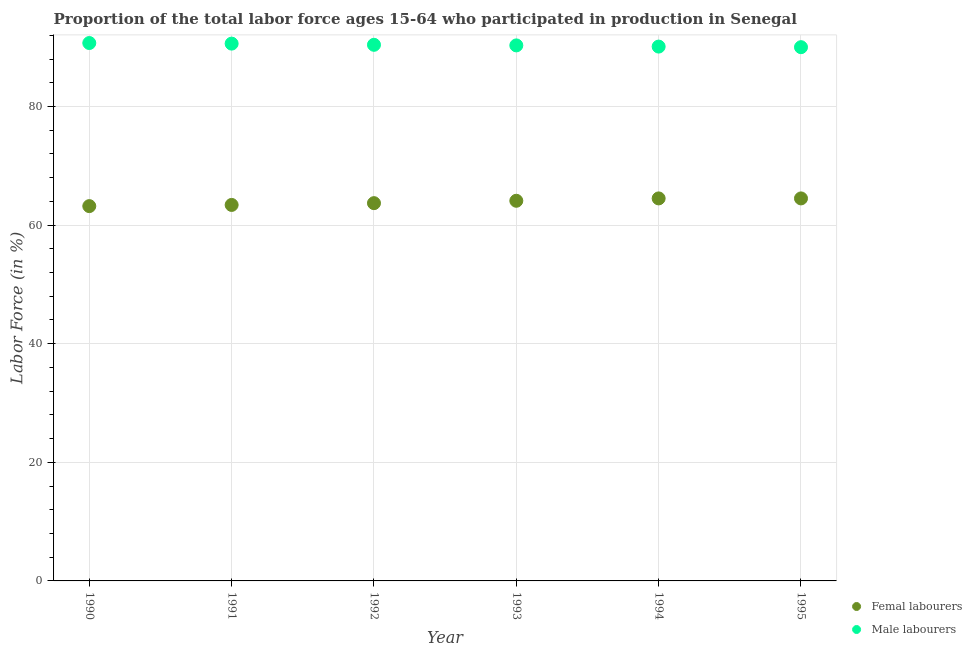How many different coloured dotlines are there?
Provide a succinct answer. 2. What is the percentage of male labour force in 1992?
Provide a short and direct response. 90.4. Across all years, what is the maximum percentage of male labour force?
Your response must be concise. 90.7. Across all years, what is the minimum percentage of male labour force?
Give a very brief answer. 90. In which year was the percentage of female labor force maximum?
Your response must be concise. 1994. What is the total percentage of female labor force in the graph?
Your response must be concise. 383.4. What is the difference between the percentage of male labour force in 1990 and that in 1993?
Keep it short and to the point. 0.4. What is the difference between the percentage of male labour force in 1994 and the percentage of female labor force in 1995?
Offer a terse response. 25.6. What is the average percentage of male labour force per year?
Ensure brevity in your answer.  90.35. In the year 1991, what is the difference between the percentage of female labor force and percentage of male labour force?
Your answer should be compact. -27.2. In how many years, is the percentage of female labor force greater than 4 %?
Provide a succinct answer. 6. What is the ratio of the percentage of female labor force in 1990 to that in 1992?
Your answer should be very brief. 0.99. What is the difference between the highest and the second highest percentage of male labour force?
Offer a terse response. 0.1. What is the difference between the highest and the lowest percentage of female labor force?
Your response must be concise. 1.3. In how many years, is the percentage of male labour force greater than the average percentage of male labour force taken over all years?
Provide a succinct answer. 3. Is the sum of the percentage of male labour force in 1990 and 1992 greater than the maximum percentage of female labor force across all years?
Your answer should be compact. Yes. Is the percentage of female labor force strictly greater than the percentage of male labour force over the years?
Offer a terse response. No. Is the percentage of female labor force strictly less than the percentage of male labour force over the years?
Give a very brief answer. Yes. How many dotlines are there?
Keep it short and to the point. 2. Are the values on the major ticks of Y-axis written in scientific E-notation?
Provide a short and direct response. No. Does the graph contain any zero values?
Keep it short and to the point. No. Where does the legend appear in the graph?
Provide a succinct answer. Bottom right. How are the legend labels stacked?
Keep it short and to the point. Vertical. What is the title of the graph?
Offer a terse response. Proportion of the total labor force ages 15-64 who participated in production in Senegal. Does "Nitrous oxide" appear as one of the legend labels in the graph?
Offer a very short reply. No. What is the label or title of the X-axis?
Offer a very short reply. Year. What is the Labor Force (in %) in Femal labourers in 1990?
Give a very brief answer. 63.2. What is the Labor Force (in %) in Male labourers in 1990?
Keep it short and to the point. 90.7. What is the Labor Force (in %) of Femal labourers in 1991?
Provide a succinct answer. 63.4. What is the Labor Force (in %) in Male labourers in 1991?
Provide a succinct answer. 90.6. What is the Labor Force (in %) in Femal labourers in 1992?
Give a very brief answer. 63.7. What is the Labor Force (in %) in Male labourers in 1992?
Ensure brevity in your answer.  90.4. What is the Labor Force (in %) in Femal labourers in 1993?
Make the answer very short. 64.1. What is the Labor Force (in %) of Male labourers in 1993?
Offer a very short reply. 90.3. What is the Labor Force (in %) in Femal labourers in 1994?
Give a very brief answer. 64.5. What is the Labor Force (in %) of Male labourers in 1994?
Provide a short and direct response. 90.1. What is the Labor Force (in %) in Femal labourers in 1995?
Your answer should be very brief. 64.5. Across all years, what is the maximum Labor Force (in %) in Femal labourers?
Your answer should be compact. 64.5. Across all years, what is the maximum Labor Force (in %) of Male labourers?
Keep it short and to the point. 90.7. Across all years, what is the minimum Labor Force (in %) in Femal labourers?
Your answer should be compact. 63.2. Across all years, what is the minimum Labor Force (in %) of Male labourers?
Provide a short and direct response. 90. What is the total Labor Force (in %) of Femal labourers in the graph?
Your answer should be compact. 383.4. What is the total Labor Force (in %) in Male labourers in the graph?
Provide a succinct answer. 542.1. What is the difference between the Labor Force (in %) of Femal labourers in 1990 and that in 1991?
Give a very brief answer. -0.2. What is the difference between the Labor Force (in %) of Male labourers in 1990 and that in 1991?
Give a very brief answer. 0.1. What is the difference between the Labor Force (in %) of Femal labourers in 1990 and that in 1992?
Provide a succinct answer. -0.5. What is the difference between the Labor Force (in %) in Male labourers in 1990 and that in 1994?
Ensure brevity in your answer.  0.6. What is the difference between the Labor Force (in %) of Male labourers in 1990 and that in 1995?
Offer a terse response. 0.7. What is the difference between the Labor Force (in %) in Femal labourers in 1991 and that in 1992?
Your answer should be compact. -0.3. What is the difference between the Labor Force (in %) of Femal labourers in 1991 and that in 1993?
Offer a very short reply. -0.7. What is the difference between the Labor Force (in %) in Male labourers in 1992 and that in 1993?
Offer a very short reply. 0.1. What is the difference between the Labor Force (in %) in Femal labourers in 1992 and that in 1994?
Offer a very short reply. -0.8. What is the difference between the Labor Force (in %) of Male labourers in 1992 and that in 1994?
Your answer should be compact. 0.3. What is the difference between the Labor Force (in %) in Femal labourers in 1993 and that in 1994?
Offer a terse response. -0.4. What is the difference between the Labor Force (in %) in Male labourers in 1993 and that in 1995?
Ensure brevity in your answer.  0.3. What is the difference between the Labor Force (in %) in Femal labourers in 1990 and the Labor Force (in %) in Male labourers in 1991?
Make the answer very short. -27.4. What is the difference between the Labor Force (in %) of Femal labourers in 1990 and the Labor Force (in %) of Male labourers in 1992?
Your response must be concise. -27.2. What is the difference between the Labor Force (in %) in Femal labourers in 1990 and the Labor Force (in %) in Male labourers in 1993?
Provide a short and direct response. -27.1. What is the difference between the Labor Force (in %) in Femal labourers in 1990 and the Labor Force (in %) in Male labourers in 1994?
Provide a short and direct response. -26.9. What is the difference between the Labor Force (in %) of Femal labourers in 1990 and the Labor Force (in %) of Male labourers in 1995?
Keep it short and to the point. -26.8. What is the difference between the Labor Force (in %) in Femal labourers in 1991 and the Labor Force (in %) in Male labourers in 1992?
Make the answer very short. -27. What is the difference between the Labor Force (in %) of Femal labourers in 1991 and the Labor Force (in %) of Male labourers in 1993?
Make the answer very short. -26.9. What is the difference between the Labor Force (in %) in Femal labourers in 1991 and the Labor Force (in %) in Male labourers in 1994?
Your response must be concise. -26.7. What is the difference between the Labor Force (in %) of Femal labourers in 1991 and the Labor Force (in %) of Male labourers in 1995?
Provide a short and direct response. -26.6. What is the difference between the Labor Force (in %) in Femal labourers in 1992 and the Labor Force (in %) in Male labourers in 1993?
Provide a succinct answer. -26.6. What is the difference between the Labor Force (in %) of Femal labourers in 1992 and the Labor Force (in %) of Male labourers in 1994?
Provide a short and direct response. -26.4. What is the difference between the Labor Force (in %) in Femal labourers in 1992 and the Labor Force (in %) in Male labourers in 1995?
Ensure brevity in your answer.  -26.3. What is the difference between the Labor Force (in %) of Femal labourers in 1993 and the Labor Force (in %) of Male labourers in 1994?
Offer a very short reply. -26. What is the difference between the Labor Force (in %) of Femal labourers in 1993 and the Labor Force (in %) of Male labourers in 1995?
Your answer should be very brief. -25.9. What is the difference between the Labor Force (in %) in Femal labourers in 1994 and the Labor Force (in %) in Male labourers in 1995?
Ensure brevity in your answer.  -25.5. What is the average Labor Force (in %) of Femal labourers per year?
Your answer should be very brief. 63.9. What is the average Labor Force (in %) in Male labourers per year?
Your response must be concise. 90.35. In the year 1990, what is the difference between the Labor Force (in %) of Femal labourers and Labor Force (in %) of Male labourers?
Make the answer very short. -27.5. In the year 1991, what is the difference between the Labor Force (in %) of Femal labourers and Labor Force (in %) of Male labourers?
Make the answer very short. -27.2. In the year 1992, what is the difference between the Labor Force (in %) in Femal labourers and Labor Force (in %) in Male labourers?
Ensure brevity in your answer.  -26.7. In the year 1993, what is the difference between the Labor Force (in %) in Femal labourers and Labor Force (in %) in Male labourers?
Your answer should be very brief. -26.2. In the year 1994, what is the difference between the Labor Force (in %) of Femal labourers and Labor Force (in %) of Male labourers?
Keep it short and to the point. -25.6. In the year 1995, what is the difference between the Labor Force (in %) of Femal labourers and Labor Force (in %) of Male labourers?
Give a very brief answer. -25.5. What is the ratio of the Labor Force (in %) in Femal labourers in 1990 to that in 1991?
Provide a short and direct response. 1. What is the ratio of the Labor Force (in %) in Femal labourers in 1990 to that in 1993?
Give a very brief answer. 0.99. What is the ratio of the Labor Force (in %) of Male labourers in 1990 to that in 1993?
Give a very brief answer. 1. What is the ratio of the Labor Force (in %) of Femal labourers in 1990 to that in 1994?
Offer a very short reply. 0.98. What is the ratio of the Labor Force (in %) in Male labourers in 1990 to that in 1994?
Ensure brevity in your answer.  1.01. What is the ratio of the Labor Force (in %) in Femal labourers in 1990 to that in 1995?
Ensure brevity in your answer.  0.98. What is the ratio of the Labor Force (in %) in Male labourers in 1990 to that in 1995?
Your answer should be compact. 1.01. What is the ratio of the Labor Force (in %) of Femal labourers in 1991 to that in 1992?
Your answer should be compact. 1. What is the ratio of the Labor Force (in %) in Femal labourers in 1991 to that in 1994?
Your response must be concise. 0.98. What is the ratio of the Labor Force (in %) of Male labourers in 1991 to that in 1994?
Offer a very short reply. 1.01. What is the ratio of the Labor Force (in %) of Femal labourers in 1991 to that in 1995?
Ensure brevity in your answer.  0.98. What is the ratio of the Labor Force (in %) of Femal labourers in 1992 to that in 1993?
Provide a succinct answer. 0.99. What is the ratio of the Labor Force (in %) of Male labourers in 1992 to that in 1993?
Your answer should be compact. 1. What is the ratio of the Labor Force (in %) in Femal labourers in 1992 to that in 1994?
Provide a succinct answer. 0.99. What is the ratio of the Labor Force (in %) of Male labourers in 1992 to that in 1994?
Offer a very short reply. 1. What is the ratio of the Labor Force (in %) in Femal labourers in 1992 to that in 1995?
Your answer should be compact. 0.99. What is the ratio of the Labor Force (in %) of Male labourers in 1993 to that in 1994?
Ensure brevity in your answer.  1. What is the ratio of the Labor Force (in %) of Male labourers in 1993 to that in 1995?
Ensure brevity in your answer.  1. What is the difference between the highest and the second highest Labor Force (in %) in Femal labourers?
Your response must be concise. 0. What is the difference between the highest and the lowest Labor Force (in %) in Femal labourers?
Your answer should be compact. 1.3. What is the difference between the highest and the lowest Labor Force (in %) in Male labourers?
Ensure brevity in your answer.  0.7. 